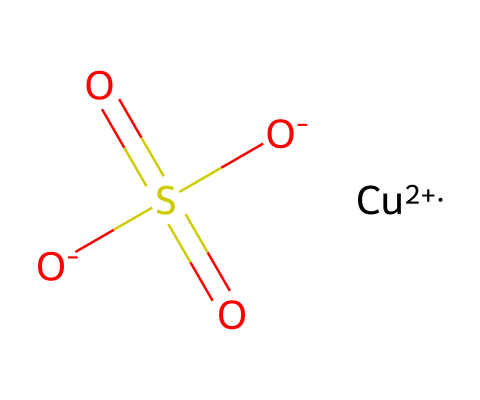What is the central metal atom in this compound? In the SMILES representation, the presence of "Cu" indicates that copper is the central metal atom in this compound.
Answer: copper How many sulfur atoms are present in the structure? The "S" in the SMILES indicates there is one sulfur atom, and there are no additional sulfur atoms specified in the structure.
Answer: one What is the oxidation state of the copper in this compound? The notation "[Cu+2]" indicates that the copper is in a +2 oxidation state, as shown by the "+2" following the element symbol.
Answer: +2 What functional groups are represented in this chemical structure? The "O-]S(=O)(=O)[O-" portion indicates a sulfonate group, characterized by the sulfur atom bonded to three oxygen atoms, along with a copper ion, which classifies it as a copper sulfate compound.
Answer: sulfonate Which type of fungicide is copper sulfate classified as? Given its chemical nature and function, copper sulfate is classified as an inorganic fungicide, primarily used for its antimicrobial properties in agriculture.
Answer: inorganic How many oxygen atoms are present in the chemical structure? The SMILES shows there are four oxygen atoms: one is bonded to the copper and the other three are indicated by "O" in the sulfonate group.
Answer: four What is the overall charge of the chemical structure? The SMILES notation indicates that copper has a +2 charge while the three oxygens of the sulfonate contribute a total of -2 charge, resulting in a neutral overall charge for the compound.
Answer: neutral 